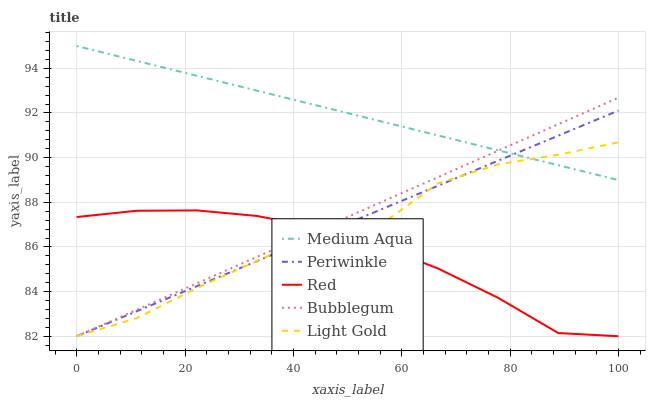Does Light Gold have the minimum area under the curve?
Answer yes or no. No. Does Light Gold have the maximum area under the curve?
Answer yes or no. No. Is Medium Aqua the smoothest?
Answer yes or no. No. Is Medium Aqua the roughest?
Answer yes or no. No. Does Medium Aqua have the lowest value?
Answer yes or no. No. Does Light Gold have the highest value?
Answer yes or no. No. Is Red less than Medium Aqua?
Answer yes or no. Yes. Is Medium Aqua greater than Red?
Answer yes or no. Yes. Does Red intersect Medium Aqua?
Answer yes or no. No. 